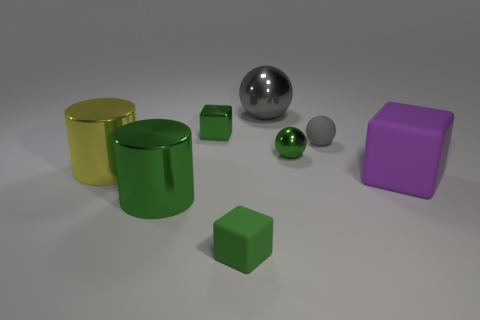Subtract all tiny shiny blocks. How many blocks are left? 2 Subtract all green cubes. How many cubes are left? 1 Add 1 purple rubber blocks. How many objects exist? 9 Subtract 0 gray cylinders. How many objects are left? 8 Subtract all balls. How many objects are left? 5 Subtract 2 cylinders. How many cylinders are left? 0 Subtract all purple balls. Subtract all red cylinders. How many balls are left? 3 Subtract all brown balls. How many brown blocks are left? 0 Subtract all purple rubber cubes. Subtract all large green shiny things. How many objects are left? 6 Add 7 small rubber cubes. How many small rubber cubes are left? 8 